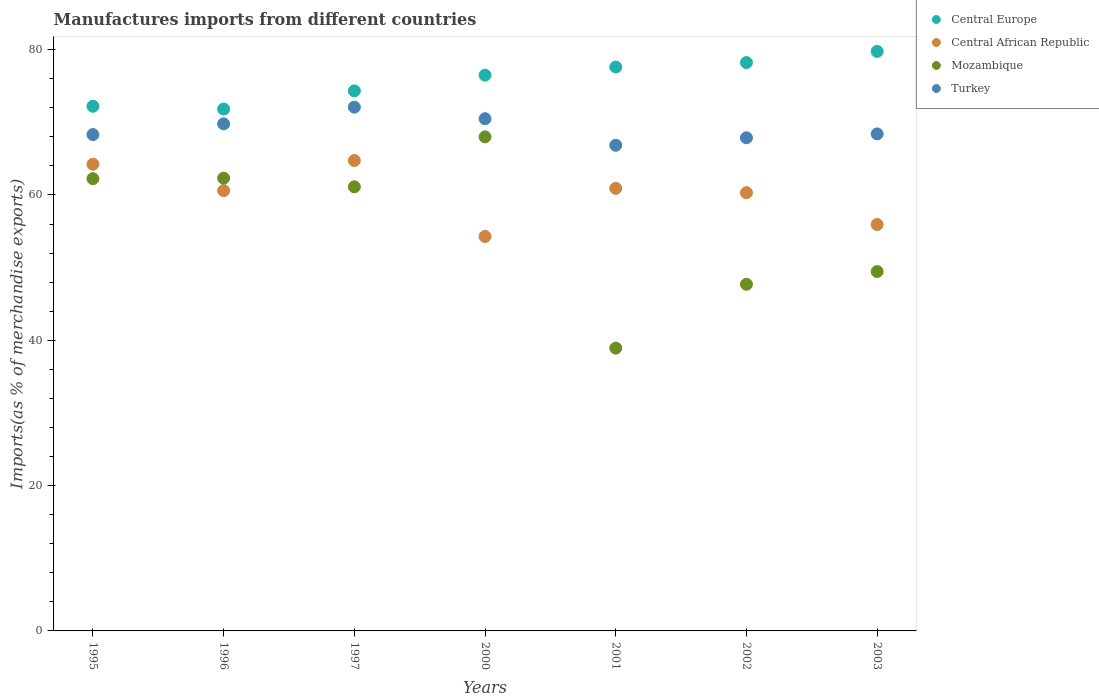Is the number of dotlines equal to the number of legend labels?
Offer a very short reply. Yes. What is the percentage of imports to different countries in Turkey in 1996?
Make the answer very short. 69.78. Across all years, what is the maximum percentage of imports to different countries in Mozambique?
Ensure brevity in your answer.  67.99. Across all years, what is the minimum percentage of imports to different countries in Central Europe?
Ensure brevity in your answer.  71.82. What is the total percentage of imports to different countries in Central Europe in the graph?
Give a very brief answer. 530.41. What is the difference between the percentage of imports to different countries in Turkey in 1997 and that in 2003?
Keep it short and to the point. 3.68. What is the difference between the percentage of imports to different countries in Turkey in 2002 and the percentage of imports to different countries in Central African Republic in 2000?
Your answer should be very brief. 13.58. What is the average percentage of imports to different countries in Turkey per year?
Your answer should be very brief. 69.11. In the year 2002, what is the difference between the percentage of imports to different countries in Central African Republic and percentage of imports to different countries in Mozambique?
Provide a short and direct response. 12.6. In how many years, is the percentage of imports to different countries in Central African Republic greater than 4 %?
Keep it short and to the point. 7. What is the ratio of the percentage of imports to different countries in Central Europe in 1996 to that in 2002?
Provide a succinct answer. 0.92. Is the percentage of imports to different countries in Turkey in 1995 less than that in 2003?
Give a very brief answer. Yes. What is the difference between the highest and the second highest percentage of imports to different countries in Turkey?
Offer a terse response. 1.59. What is the difference between the highest and the lowest percentage of imports to different countries in Mozambique?
Offer a terse response. 29.07. Is the sum of the percentage of imports to different countries in Central African Republic in 1995 and 2000 greater than the maximum percentage of imports to different countries in Central Europe across all years?
Your answer should be very brief. Yes. Is it the case that in every year, the sum of the percentage of imports to different countries in Central African Republic and percentage of imports to different countries in Turkey  is greater than the sum of percentage of imports to different countries in Central Europe and percentage of imports to different countries in Mozambique?
Provide a short and direct response. Yes. Is it the case that in every year, the sum of the percentage of imports to different countries in Turkey and percentage of imports to different countries in Mozambique  is greater than the percentage of imports to different countries in Central Europe?
Offer a very short reply. Yes. Is the percentage of imports to different countries in Central Europe strictly less than the percentage of imports to different countries in Mozambique over the years?
Your response must be concise. No. How many dotlines are there?
Your answer should be compact. 4. How many years are there in the graph?
Provide a succinct answer. 7. Are the values on the major ticks of Y-axis written in scientific E-notation?
Give a very brief answer. No. Does the graph contain any zero values?
Your answer should be very brief. No. How many legend labels are there?
Your answer should be compact. 4. What is the title of the graph?
Your response must be concise. Manufactures imports from different countries. Does "Eritrea" appear as one of the legend labels in the graph?
Offer a terse response. No. What is the label or title of the X-axis?
Provide a succinct answer. Years. What is the label or title of the Y-axis?
Make the answer very short. Imports(as % of merchandise exports). What is the Imports(as % of merchandise exports) in Central Europe in 1995?
Offer a terse response. 72.2. What is the Imports(as % of merchandise exports) in Central African Republic in 1995?
Make the answer very short. 64.22. What is the Imports(as % of merchandise exports) of Mozambique in 1995?
Offer a terse response. 62.24. What is the Imports(as % of merchandise exports) of Turkey in 1995?
Provide a short and direct response. 68.31. What is the Imports(as % of merchandise exports) of Central Europe in 1996?
Your answer should be very brief. 71.82. What is the Imports(as % of merchandise exports) of Central African Republic in 1996?
Provide a succinct answer. 60.6. What is the Imports(as % of merchandise exports) in Mozambique in 1996?
Keep it short and to the point. 62.31. What is the Imports(as % of merchandise exports) in Turkey in 1996?
Make the answer very short. 69.78. What is the Imports(as % of merchandise exports) in Central Europe in 1997?
Ensure brevity in your answer.  74.32. What is the Imports(as % of merchandise exports) of Central African Republic in 1997?
Your answer should be very brief. 64.74. What is the Imports(as % of merchandise exports) of Mozambique in 1997?
Your response must be concise. 61.12. What is the Imports(as % of merchandise exports) of Turkey in 1997?
Ensure brevity in your answer.  72.08. What is the Imports(as % of merchandise exports) in Central Europe in 2000?
Your answer should be compact. 76.49. What is the Imports(as % of merchandise exports) in Central African Republic in 2000?
Your response must be concise. 54.28. What is the Imports(as % of merchandise exports) of Mozambique in 2000?
Ensure brevity in your answer.  67.99. What is the Imports(as % of merchandise exports) in Turkey in 2000?
Give a very brief answer. 70.49. What is the Imports(as % of merchandise exports) in Central Europe in 2001?
Your answer should be very brief. 77.61. What is the Imports(as % of merchandise exports) in Central African Republic in 2001?
Your answer should be compact. 60.91. What is the Imports(as % of merchandise exports) of Mozambique in 2001?
Make the answer very short. 38.92. What is the Imports(as % of merchandise exports) in Turkey in 2001?
Offer a terse response. 66.84. What is the Imports(as % of merchandise exports) of Central Europe in 2002?
Your response must be concise. 78.22. What is the Imports(as % of merchandise exports) in Central African Republic in 2002?
Provide a short and direct response. 60.3. What is the Imports(as % of merchandise exports) of Mozambique in 2002?
Provide a short and direct response. 47.71. What is the Imports(as % of merchandise exports) of Turkey in 2002?
Give a very brief answer. 67.86. What is the Imports(as % of merchandise exports) of Central Europe in 2003?
Keep it short and to the point. 79.75. What is the Imports(as % of merchandise exports) in Central African Republic in 2003?
Give a very brief answer. 55.93. What is the Imports(as % of merchandise exports) of Mozambique in 2003?
Offer a very short reply. 49.46. What is the Imports(as % of merchandise exports) in Turkey in 2003?
Offer a very short reply. 68.4. Across all years, what is the maximum Imports(as % of merchandise exports) in Central Europe?
Your answer should be very brief. 79.75. Across all years, what is the maximum Imports(as % of merchandise exports) of Central African Republic?
Make the answer very short. 64.74. Across all years, what is the maximum Imports(as % of merchandise exports) in Mozambique?
Keep it short and to the point. 67.99. Across all years, what is the maximum Imports(as % of merchandise exports) of Turkey?
Provide a succinct answer. 72.08. Across all years, what is the minimum Imports(as % of merchandise exports) in Central Europe?
Provide a succinct answer. 71.82. Across all years, what is the minimum Imports(as % of merchandise exports) of Central African Republic?
Your answer should be very brief. 54.28. Across all years, what is the minimum Imports(as % of merchandise exports) in Mozambique?
Your answer should be compact. 38.92. Across all years, what is the minimum Imports(as % of merchandise exports) of Turkey?
Offer a very short reply. 66.84. What is the total Imports(as % of merchandise exports) in Central Europe in the graph?
Your answer should be compact. 530.41. What is the total Imports(as % of merchandise exports) of Central African Republic in the graph?
Offer a terse response. 420.98. What is the total Imports(as % of merchandise exports) in Mozambique in the graph?
Offer a terse response. 389.74. What is the total Imports(as % of merchandise exports) in Turkey in the graph?
Keep it short and to the point. 483.76. What is the difference between the Imports(as % of merchandise exports) of Central Europe in 1995 and that in 1996?
Offer a very short reply. 0.38. What is the difference between the Imports(as % of merchandise exports) of Central African Republic in 1995 and that in 1996?
Make the answer very short. 3.63. What is the difference between the Imports(as % of merchandise exports) in Mozambique in 1995 and that in 1996?
Your answer should be very brief. -0.07. What is the difference between the Imports(as % of merchandise exports) in Turkey in 1995 and that in 1996?
Keep it short and to the point. -1.47. What is the difference between the Imports(as % of merchandise exports) in Central Europe in 1995 and that in 1997?
Give a very brief answer. -2.12. What is the difference between the Imports(as % of merchandise exports) of Central African Republic in 1995 and that in 1997?
Your answer should be very brief. -0.51. What is the difference between the Imports(as % of merchandise exports) of Mozambique in 1995 and that in 1997?
Your response must be concise. 1.12. What is the difference between the Imports(as % of merchandise exports) in Turkey in 1995 and that in 1997?
Keep it short and to the point. -3.77. What is the difference between the Imports(as % of merchandise exports) of Central Europe in 1995 and that in 2000?
Your answer should be compact. -4.28. What is the difference between the Imports(as % of merchandise exports) in Central African Republic in 1995 and that in 2000?
Give a very brief answer. 9.94. What is the difference between the Imports(as % of merchandise exports) in Mozambique in 1995 and that in 2000?
Your answer should be very brief. -5.75. What is the difference between the Imports(as % of merchandise exports) of Turkey in 1995 and that in 2000?
Provide a succinct answer. -2.18. What is the difference between the Imports(as % of merchandise exports) in Central Europe in 1995 and that in 2001?
Provide a short and direct response. -5.4. What is the difference between the Imports(as % of merchandise exports) in Central African Republic in 1995 and that in 2001?
Your answer should be compact. 3.32. What is the difference between the Imports(as % of merchandise exports) of Mozambique in 1995 and that in 2001?
Make the answer very short. 23.32. What is the difference between the Imports(as % of merchandise exports) of Turkey in 1995 and that in 2001?
Your answer should be very brief. 1.47. What is the difference between the Imports(as % of merchandise exports) of Central Europe in 1995 and that in 2002?
Give a very brief answer. -6.01. What is the difference between the Imports(as % of merchandise exports) of Central African Republic in 1995 and that in 2002?
Give a very brief answer. 3.92. What is the difference between the Imports(as % of merchandise exports) in Mozambique in 1995 and that in 2002?
Ensure brevity in your answer.  14.53. What is the difference between the Imports(as % of merchandise exports) of Turkey in 1995 and that in 2002?
Provide a short and direct response. 0.44. What is the difference between the Imports(as % of merchandise exports) in Central Europe in 1995 and that in 2003?
Your response must be concise. -7.55. What is the difference between the Imports(as % of merchandise exports) in Central African Republic in 1995 and that in 2003?
Your answer should be compact. 8.29. What is the difference between the Imports(as % of merchandise exports) in Mozambique in 1995 and that in 2003?
Your answer should be compact. 12.78. What is the difference between the Imports(as % of merchandise exports) in Turkey in 1995 and that in 2003?
Your answer should be very brief. -0.09. What is the difference between the Imports(as % of merchandise exports) in Central Europe in 1996 and that in 1997?
Offer a very short reply. -2.5. What is the difference between the Imports(as % of merchandise exports) in Central African Republic in 1996 and that in 1997?
Your response must be concise. -4.14. What is the difference between the Imports(as % of merchandise exports) in Mozambique in 1996 and that in 1997?
Give a very brief answer. 1.19. What is the difference between the Imports(as % of merchandise exports) of Turkey in 1996 and that in 1997?
Make the answer very short. -2.3. What is the difference between the Imports(as % of merchandise exports) of Central Europe in 1996 and that in 2000?
Give a very brief answer. -4.66. What is the difference between the Imports(as % of merchandise exports) of Central African Republic in 1996 and that in 2000?
Offer a very short reply. 6.31. What is the difference between the Imports(as % of merchandise exports) in Mozambique in 1996 and that in 2000?
Provide a short and direct response. -5.68. What is the difference between the Imports(as % of merchandise exports) of Turkey in 1996 and that in 2000?
Provide a short and direct response. -0.71. What is the difference between the Imports(as % of merchandise exports) of Central Europe in 1996 and that in 2001?
Give a very brief answer. -5.78. What is the difference between the Imports(as % of merchandise exports) of Central African Republic in 1996 and that in 2001?
Provide a short and direct response. -0.31. What is the difference between the Imports(as % of merchandise exports) in Mozambique in 1996 and that in 2001?
Offer a very short reply. 23.39. What is the difference between the Imports(as % of merchandise exports) in Turkey in 1996 and that in 2001?
Your answer should be compact. 2.95. What is the difference between the Imports(as % of merchandise exports) in Central Europe in 1996 and that in 2002?
Offer a terse response. -6.39. What is the difference between the Imports(as % of merchandise exports) of Central African Republic in 1996 and that in 2002?
Your answer should be compact. 0.29. What is the difference between the Imports(as % of merchandise exports) of Mozambique in 1996 and that in 2002?
Provide a short and direct response. 14.6. What is the difference between the Imports(as % of merchandise exports) in Turkey in 1996 and that in 2002?
Offer a very short reply. 1.92. What is the difference between the Imports(as % of merchandise exports) in Central Europe in 1996 and that in 2003?
Give a very brief answer. -7.93. What is the difference between the Imports(as % of merchandise exports) of Central African Republic in 1996 and that in 2003?
Make the answer very short. 4.66. What is the difference between the Imports(as % of merchandise exports) in Mozambique in 1996 and that in 2003?
Your answer should be very brief. 12.85. What is the difference between the Imports(as % of merchandise exports) in Turkey in 1996 and that in 2003?
Give a very brief answer. 1.38. What is the difference between the Imports(as % of merchandise exports) of Central Europe in 1997 and that in 2000?
Provide a succinct answer. -2.16. What is the difference between the Imports(as % of merchandise exports) of Central African Republic in 1997 and that in 2000?
Offer a very short reply. 10.45. What is the difference between the Imports(as % of merchandise exports) of Mozambique in 1997 and that in 2000?
Offer a very short reply. -6.88. What is the difference between the Imports(as % of merchandise exports) of Turkey in 1997 and that in 2000?
Make the answer very short. 1.59. What is the difference between the Imports(as % of merchandise exports) in Central Europe in 1997 and that in 2001?
Provide a short and direct response. -3.29. What is the difference between the Imports(as % of merchandise exports) of Central African Republic in 1997 and that in 2001?
Provide a short and direct response. 3.83. What is the difference between the Imports(as % of merchandise exports) of Mozambique in 1997 and that in 2001?
Keep it short and to the point. 22.2. What is the difference between the Imports(as % of merchandise exports) in Turkey in 1997 and that in 2001?
Your answer should be compact. 5.25. What is the difference between the Imports(as % of merchandise exports) in Central Europe in 1997 and that in 2002?
Provide a succinct answer. -3.89. What is the difference between the Imports(as % of merchandise exports) of Central African Republic in 1997 and that in 2002?
Offer a terse response. 4.43. What is the difference between the Imports(as % of merchandise exports) of Mozambique in 1997 and that in 2002?
Provide a succinct answer. 13.41. What is the difference between the Imports(as % of merchandise exports) in Turkey in 1997 and that in 2002?
Give a very brief answer. 4.22. What is the difference between the Imports(as % of merchandise exports) in Central Europe in 1997 and that in 2003?
Offer a very short reply. -5.43. What is the difference between the Imports(as % of merchandise exports) in Central African Republic in 1997 and that in 2003?
Make the answer very short. 8.8. What is the difference between the Imports(as % of merchandise exports) in Mozambique in 1997 and that in 2003?
Your answer should be compact. 11.66. What is the difference between the Imports(as % of merchandise exports) of Turkey in 1997 and that in 2003?
Offer a terse response. 3.68. What is the difference between the Imports(as % of merchandise exports) in Central Europe in 2000 and that in 2001?
Your answer should be very brief. -1.12. What is the difference between the Imports(as % of merchandise exports) in Central African Republic in 2000 and that in 2001?
Make the answer very short. -6.62. What is the difference between the Imports(as % of merchandise exports) of Mozambique in 2000 and that in 2001?
Your response must be concise. 29.07. What is the difference between the Imports(as % of merchandise exports) of Turkey in 2000 and that in 2001?
Give a very brief answer. 3.65. What is the difference between the Imports(as % of merchandise exports) of Central Europe in 2000 and that in 2002?
Ensure brevity in your answer.  -1.73. What is the difference between the Imports(as % of merchandise exports) of Central African Republic in 2000 and that in 2002?
Your answer should be very brief. -6.02. What is the difference between the Imports(as % of merchandise exports) in Mozambique in 2000 and that in 2002?
Provide a short and direct response. 20.29. What is the difference between the Imports(as % of merchandise exports) of Turkey in 2000 and that in 2002?
Ensure brevity in your answer.  2.63. What is the difference between the Imports(as % of merchandise exports) in Central Europe in 2000 and that in 2003?
Your answer should be compact. -3.27. What is the difference between the Imports(as % of merchandise exports) in Central African Republic in 2000 and that in 2003?
Your answer should be very brief. -1.65. What is the difference between the Imports(as % of merchandise exports) in Mozambique in 2000 and that in 2003?
Offer a very short reply. 18.54. What is the difference between the Imports(as % of merchandise exports) in Turkey in 2000 and that in 2003?
Your answer should be compact. 2.09. What is the difference between the Imports(as % of merchandise exports) of Central Europe in 2001 and that in 2002?
Give a very brief answer. -0.61. What is the difference between the Imports(as % of merchandise exports) of Central African Republic in 2001 and that in 2002?
Ensure brevity in your answer.  0.6. What is the difference between the Imports(as % of merchandise exports) in Mozambique in 2001 and that in 2002?
Ensure brevity in your answer.  -8.79. What is the difference between the Imports(as % of merchandise exports) of Turkey in 2001 and that in 2002?
Ensure brevity in your answer.  -1.03. What is the difference between the Imports(as % of merchandise exports) of Central Europe in 2001 and that in 2003?
Your response must be concise. -2.15. What is the difference between the Imports(as % of merchandise exports) in Central African Republic in 2001 and that in 2003?
Give a very brief answer. 4.97. What is the difference between the Imports(as % of merchandise exports) in Mozambique in 2001 and that in 2003?
Ensure brevity in your answer.  -10.54. What is the difference between the Imports(as % of merchandise exports) in Turkey in 2001 and that in 2003?
Provide a succinct answer. -1.57. What is the difference between the Imports(as % of merchandise exports) in Central Europe in 2002 and that in 2003?
Give a very brief answer. -1.54. What is the difference between the Imports(as % of merchandise exports) of Central African Republic in 2002 and that in 2003?
Ensure brevity in your answer.  4.37. What is the difference between the Imports(as % of merchandise exports) in Mozambique in 2002 and that in 2003?
Provide a succinct answer. -1.75. What is the difference between the Imports(as % of merchandise exports) of Turkey in 2002 and that in 2003?
Offer a very short reply. -0.54. What is the difference between the Imports(as % of merchandise exports) in Central Europe in 1995 and the Imports(as % of merchandise exports) in Central African Republic in 1996?
Keep it short and to the point. 11.61. What is the difference between the Imports(as % of merchandise exports) of Central Europe in 1995 and the Imports(as % of merchandise exports) of Mozambique in 1996?
Provide a short and direct response. 9.89. What is the difference between the Imports(as % of merchandise exports) in Central Europe in 1995 and the Imports(as % of merchandise exports) in Turkey in 1996?
Offer a very short reply. 2.42. What is the difference between the Imports(as % of merchandise exports) in Central African Republic in 1995 and the Imports(as % of merchandise exports) in Mozambique in 1996?
Offer a terse response. 1.92. What is the difference between the Imports(as % of merchandise exports) of Central African Republic in 1995 and the Imports(as % of merchandise exports) of Turkey in 1996?
Make the answer very short. -5.56. What is the difference between the Imports(as % of merchandise exports) in Mozambique in 1995 and the Imports(as % of merchandise exports) in Turkey in 1996?
Ensure brevity in your answer.  -7.54. What is the difference between the Imports(as % of merchandise exports) in Central Europe in 1995 and the Imports(as % of merchandise exports) in Central African Republic in 1997?
Give a very brief answer. 7.47. What is the difference between the Imports(as % of merchandise exports) of Central Europe in 1995 and the Imports(as % of merchandise exports) of Mozambique in 1997?
Ensure brevity in your answer.  11.09. What is the difference between the Imports(as % of merchandise exports) in Central Europe in 1995 and the Imports(as % of merchandise exports) in Turkey in 1997?
Keep it short and to the point. 0.12. What is the difference between the Imports(as % of merchandise exports) of Central African Republic in 1995 and the Imports(as % of merchandise exports) of Mozambique in 1997?
Your answer should be compact. 3.11. What is the difference between the Imports(as % of merchandise exports) of Central African Republic in 1995 and the Imports(as % of merchandise exports) of Turkey in 1997?
Your answer should be compact. -7.86. What is the difference between the Imports(as % of merchandise exports) in Mozambique in 1995 and the Imports(as % of merchandise exports) in Turkey in 1997?
Offer a terse response. -9.84. What is the difference between the Imports(as % of merchandise exports) in Central Europe in 1995 and the Imports(as % of merchandise exports) in Central African Republic in 2000?
Make the answer very short. 17.92. What is the difference between the Imports(as % of merchandise exports) in Central Europe in 1995 and the Imports(as % of merchandise exports) in Mozambique in 2000?
Offer a terse response. 4.21. What is the difference between the Imports(as % of merchandise exports) in Central Europe in 1995 and the Imports(as % of merchandise exports) in Turkey in 2000?
Provide a succinct answer. 1.71. What is the difference between the Imports(as % of merchandise exports) in Central African Republic in 1995 and the Imports(as % of merchandise exports) in Mozambique in 2000?
Offer a very short reply. -3.77. What is the difference between the Imports(as % of merchandise exports) in Central African Republic in 1995 and the Imports(as % of merchandise exports) in Turkey in 2000?
Your answer should be compact. -6.26. What is the difference between the Imports(as % of merchandise exports) of Mozambique in 1995 and the Imports(as % of merchandise exports) of Turkey in 2000?
Offer a very short reply. -8.25. What is the difference between the Imports(as % of merchandise exports) in Central Europe in 1995 and the Imports(as % of merchandise exports) in Central African Republic in 2001?
Your response must be concise. 11.3. What is the difference between the Imports(as % of merchandise exports) in Central Europe in 1995 and the Imports(as % of merchandise exports) in Mozambique in 2001?
Offer a terse response. 33.28. What is the difference between the Imports(as % of merchandise exports) of Central Europe in 1995 and the Imports(as % of merchandise exports) of Turkey in 2001?
Offer a very short reply. 5.37. What is the difference between the Imports(as % of merchandise exports) of Central African Republic in 1995 and the Imports(as % of merchandise exports) of Mozambique in 2001?
Offer a very short reply. 25.3. What is the difference between the Imports(as % of merchandise exports) in Central African Republic in 1995 and the Imports(as % of merchandise exports) in Turkey in 2001?
Offer a terse response. -2.61. What is the difference between the Imports(as % of merchandise exports) in Mozambique in 1995 and the Imports(as % of merchandise exports) in Turkey in 2001?
Your response must be concise. -4.59. What is the difference between the Imports(as % of merchandise exports) of Central Europe in 1995 and the Imports(as % of merchandise exports) of Central African Republic in 2002?
Ensure brevity in your answer.  11.9. What is the difference between the Imports(as % of merchandise exports) of Central Europe in 1995 and the Imports(as % of merchandise exports) of Mozambique in 2002?
Offer a terse response. 24.5. What is the difference between the Imports(as % of merchandise exports) in Central Europe in 1995 and the Imports(as % of merchandise exports) in Turkey in 2002?
Give a very brief answer. 4.34. What is the difference between the Imports(as % of merchandise exports) in Central African Republic in 1995 and the Imports(as % of merchandise exports) in Mozambique in 2002?
Provide a succinct answer. 16.52. What is the difference between the Imports(as % of merchandise exports) in Central African Republic in 1995 and the Imports(as % of merchandise exports) in Turkey in 2002?
Your answer should be very brief. -3.64. What is the difference between the Imports(as % of merchandise exports) in Mozambique in 1995 and the Imports(as % of merchandise exports) in Turkey in 2002?
Give a very brief answer. -5.62. What is the difference between the Imports(as % of merchandise exports) in Central Europe in 1995 and the Imports(as % of merchandise exports) in Central African Republic in 2003?
Offer a very short reply. 16.27. What is the difference between the Imports(as % of merchandise exports) of Central Europe in 1995 and the Imports(as % of merchandise exports) of Mozambique in 2003?
Your response must be concise. 22.75. What is the difference between the Imports(as % of merchandise exports) of Central Europe in 1995 and the Imports(as % of merchandise exports) of Turkey in 2003?
Your answer should be compact. 3.8. What is the difference between the Imports(as % of merchandise exports) in Central African Republic in 1995 and the Imports(as % of merchandise exports) in Mozambique in 2003?
Your response must be concise. 14.77. What is the difference between the Imports(as % of merchandise exports) of Central African Republic in 1995 and the Imports(as % of merchandise exports) of Turkey in 2003?
Ensure brevity in your answer.  -4.18. What is the difference between the Imports(as % of merchandise exports) of Mozambique in 1995 and the Imports(as % of merchandise exports) of Turkey in 2003?
Offer a terse response. -6.16. What is the difference between the Imports(as % of merchandise exports) in Central Europe in 1996 and the Imports(as % of merchandise exports) in Central African Republic in 1997?
Provide a succinct answer. 7.09. What is the difference between the Imports(as % of merchandise exports) in Central Europe in 1996 and the Imports(as % of merchandise exports) in Mozambique in 1997?
Keep it short and to the point. 10.71. What is the difference between the Imports(as % of merchandise exports) of Central Europe in 1996 and the Imports(as % of merchandise exports) of Turkey in 1997?
Offer a terse response. -0.26. What is the difference between the Imports(as % of merchandise exports) in Central African Republic in 1996 and the Imports(as % of merchandise exports) in Mozambique in 1997?
Your answer should be very brief. -0.52. What is the difference between the Imports(as % of merchandise exports) in Central African Republic in 1996 and the Imports(as % of merchandise exports) in Turkey in 1997?
Offer a terse response. -11.49. What is the difference between the Imports(as % of merchandise exports) in Mozambique in 1996 and the Imports(as % of merchandise exports) in Turkey in 1997?
Provide a short and direct response. -9.77. What is the difference between the Imports(as % of merchandise exports) in Central Europe in 1996 and the Imports(as % of merchandise exports) in Central African Republic in 2000?
Give a very brief answer. 17.54. What is the difference between the Imports(as % of merchandise exports) in Central Europe in 1996 and the Imports(as % of merchandise exports) in Mozambique in 2000?
Provide a succinct answer. 3.83. What is the difference between the Imports(as % of merchandise exports) of Central Europe in 1996 and the Imports(as % of merchandise exports) of Turkey in 2000?
Your answer should be compact. 1.33. What is the difference between the Imports(as % of merchandise exports) of Central African Republic in 1996 and the Imports(as % of merchandise exports) of Mozambique in 2000?
Offer a terse response. -7.4. What is the difference between the Imports(as % of merchandise exports) of Central African Republic in 1996 and the Imports(as % of merchandise exports) of Turkey in 2000?
Offer a very short reply. -9.89. What is the difference between the Imports(as % of merchandise exports) in Mozambique in 1996 and the Imports(as % of merchandise exports) in Turkey in 2000?
Your answer should be very brief. -8.18. What is the difference between the Imports(as % of merchandise exports) of Central Europe in 1996 and the Imports(as % of merchandise exports) of Central African Republic in 2001?
Give a very brief answer. 10.92. What is the difference between the Imports(as % of merchandise exports) in Central Europe in 1996 and the Imports(as % of merchandise exports) in Mozambique in 2001?
Ensure brevity in your answer.  32.9. What is the difference between the Imports(as % of merchandise exports) of Central Europe in 1996 and the Imports(as % of merchandise exports) of Turkey in 2001?
Offer a very short reply. 4.99. What is the difference between the Imports(as % of merchandise exports) of Central African Republic in 1996 and the Imports(as % of merchandise exports) of Mozambique in 2001?
Your response must be concise. 21.68. What is the difference between the Imports(as % of merchandise exports) in Central African Republic in 1996 and the Imports(as % of merchandise exports) in Turkey in 2001?
Make the answer very short. -6.24. What is the difference between the Imports(as % of merchandise exports) of Mozambique in 1996 and the Imports(as % of merchandise exports) of Turkey in 2001?
Ensure brevity in your answer.  -4.53. What is the difference between the Imports(as % of merchandise exports) in Central Europe in 1996 and the Imports(as % of merchandise exports) in Central African Republic in 2002?
Make the answer very short. 11.52. What is the difference between the Imports(as % of merchandise exports) in Central Europe in 1996 and the Imports(as % of merchandise exports) in Mozambique in 2002?
Give a very brief answer. 24.12. What is the difference between the Imports(as % of merchandise exports) in Central Europe in 1996 and the Imports(as % of merchandise exports) in Turkey in 2002?
Provide a short and direct response. 3.96. What is the difference between the Imports(as % of merchandise exports) in Central African Republic in 1996 and the Imports(as % of merchandise exports) in Mozambique in 2002?
Ensure brevity in your answer.  12.89. What is the difference between the Imports(as % of merchandise exports) in Central African Republic in 1996 and the Imports(as % of merchandise exports) in Turkey in 2002?
Give a very brief answer. -7.27. What is the difference between the Imports(as % of merchandise exports) of Mozambique in 1996 and the Imports(as % of merchandise exports) of Turkey in 2002?
Offer a terse response. -5.56. What is the difference between the Imports(as % of merchandise exports) of Central Europe in 1996 and the Imports(as % of merchandise exports) of Central African Republic in 2003?
Make the answer very short. 15.89. What is the difference between the Imports(as % of merchandise exports) in Central Europe in 1996 and the Imports(as % of merchandise exports) in Mozambique in 2003?
Give a very brief answer. 22.37. What is the difference between the Imports(as % of merchandise exports) of Central Europe in 1996 and the Imports(as % of merchandise exports) of Turkey in 2003?
Provide a succinct answer. 3.42. What is the difference between the Imports(as % of merchandise exports) of Central African Republic in 1996 and the Imports(as % of merchandise exports) of Mozambique in 2003?
Your answer should be very brief. 11.14. What is the difference between the Imports(as % of merchandise exports) in Central African Republic in 1996 and the Imports(as % of merchandise exports) in Turkey in 2003?
Make the answer very short. -7.81. What is the difference between the Imports(as % of merchandise exports) of Mozambique in 1996 and the Imports(as % of merchandise exports) of Turkey in 2003?
Keep it short and to the point. -6.09. What is the difference between the Imports(as % of merchandise exports) of Central Europe in 1997 and the Imports(as % of merchandise exports) of Central African Republic in 2000?
Your answer should be very brief. 20.04. What is the difference between the Imports(as % of merchandise exports) of Central Europe in 1997 and the Imports(as % of merchandise exports) of Mozambique in 2000?
Your answer should be compact. 6.33. What is the difference between the Imports(as % of merchandise exports) of Central Europe in 1997 and the Imports(as % of merchandise exports) of Turkey in 2000?
Ensure brevity in your answer.  3.83. What is the difference between the Imports(as % of merchandise exports) in Central African Republic in 1997 and the Imports(as % of merchandise exports) in Mozambique in 2000?
Your answer should be compact. -3.26. What is the difference between the Imports(as % of merchandise exports) of Central African Republic in 1997 and the Imports(as % of merchandise exports) of Turkey in 2000?
Your response must be concise. -5.75. What is the difference between the Imports(as % of merchandise exports) in Mozambique in 1997 and the Imports(as % of merchandise exports) in Turkey in 2000?
Your answer should be very brief. -9.37. What is the difference between the Imports(as % of merchandise exports) of Central Europe in 1997 and the Imports(as % of merchandise exports) of Central African Republic in 2001?
Your response must be concise. 13.42. What is the difference between the Imports(as % of merchandise exports) of Central Europe in 1997 and the Imports(as % of merchandise exports) of Mozambique in 2001?
Provide a short and direct response. 35.4. What is the difference between the Imports(as % of merchandise exports) in Central Europe in 1997 and the Imports(as % of merchandise exports) in Turkey in 2001?
Your response must be concise. 7.49. What is the difference between the Imports(as % of merchandise exports) of Central African Republic in 1997 and the Imports(as % of merchandise exports) of Mozambique in 2001?
Give a very brief answer. 25.82. What is the difference between the Imports(as % of merchandise exports) in Central African Republic in 1997 and the Imports(as % of merchandise exports) in Turkey in 2001?
Make the answer very short. -2.1. What is the difference between the Imports(as % of merchandise exports) of Mozambique in 1997 and the Imports(as % of merchandise exports) of Turkey in 2001?
Your answer should be very brief. -5.72. What is the difference between the Imports(as % of merchandise exports) in Central Europe in 1997 and the Imports(as % of merchandise exports) in Central African Republic in 2002?
Provide a short and direct response. 14.02. What is the difference between the Imports(as % of merchandise exports) of Central Europe in 1997 and the Imports(as % of merchandise exports) of Mozambique in 2002?
Provide a short and direct response. 26.61. What is the difference between the Imports(as % of merchandise exports) in Central Europe in 1997 and the Imports(as % of merchandise exports) in Turkey in 2002?
Provide a succinct answer. 6.46. What is the difference between the Imports(as % of merchandise exports) of Central African Republic in 1997 and the Imports(as % of merchandise exports) of Mozambique in 2002?
Make the answer very short. 17.03. What is the difference between the Imports(as % of merchandise exports) of Central African Republic in 1997 and the Imports(as % of merchandise exports) of Turkey in 2002?
Offer a very short reply. -3.13. What is the difference between the Imports(as % of merchandise exports) in Mozambique in 1997 and the Imports(as % of merchandise exports) in Turkey in 2002?
Give a very brief answer. -6.75. What is the difference between the Imports(as % of merchandise exports) of Central Europe in 1997 and the Imports(as % of merchandise exports) of Central African Republic in 2003?
Provide a short and direct response. 18.39. What is the difference between the Imports(as % of merchandise exports) of Central Europe in 1997 and the Imports(as % of merchandise exports) of Mozambique in 2003?
Provide a succinct answer. 24.86. What is the difference between the Imports(as % of merchandise exports) of Central Europe in 1997 and the Imports(as % of merchandise exports) of Turkey in 2003?
Offer a terse response. 5.92. What is the difference between the Imports(as % of merchandise exports) in Central African Republic in 1997 and the Imports(as % of merchandise exports) in Mozambique in 2003?
Your answer should be very brief. 15.28. What is the difference between the Imports(as % of merchandise exports) of Central African Republic in 1997 and the Imports(as % of merchandise exports) of Turkey in 2003?
Keep it short and to the point. -3.67. What is the difference between the Imports(as % of merchandise exports) in Mozambique in 1997 and the Imports(as % of merchandise exports) in Turkey in 2003?
Your response must be concise. -7.29. What is the difference between the Imports(as % of merchandise exports) in Central Europe in 2000 and the Imports(as % of merchandise exports) in Central African Republic in 2001?
Your answer should be very brief. 15.58. What is the difference between the Imports(as % of merchandise exports) in Central Europe in 2000 and the Imports(as % of merchandise exports) in Mozambique in 2001?
Keep it short and to the point. 37.57. What is the difference between the Imports(as % of merchandise exports) in Central Europe in 2000 and the Imports(as % of merchandise exports) in Turkey in 2001?
Make the answer very short. 9.65. What is the difference between the Imports(as % of merchandise exports) of Central African Republic in 2000 and the Imports(as % of merchandise exports) of Mozambique in 2001?
Make the answer very short. 15.36. What is the difference between the Imports(as % of merchandise exports) of Central African Republic in 2000 and the Imports(as % of merchandise exports) of Turkey in 2001?
Offer a very short reply. -12.55. What is the difference between the Imports(as % of merchandise exports) of Mozambique in 2000 and the Imports(as % of merchandise exports) of Turkey in 2001?
Give a very brief answer. 1.16. What is the difference between the Imports(as % of merchandise exports) in Central Europe in 2000 and the Imports(as % of merchandise exports) in Central African Republic in 2002?
Give a very brief answer. 16.18. What is the difference between the Imports(as % of merchandise exports) in Central Europe in 2000 and the Imports(as % of merchandise exports) in Mozambique in 2002?
Your answer should be compact. 28.78. What is the difference between the Imports(as % of merchandise exports) in Central Europe in 2000 and the Imports(as % of merchandise exports) in Turkey in 2002?
Provide a succinct answer. 8.62. What is the difference between the Imports(as % of merchandise exports) of Central African Republic in 2000 and the Imports(as % of merchandise exports) of Mozambique in 2002?
Give a very brief answer. 6.58. What is the difference between the Imports(as % of merchandise exports) in Central African Republic in 2000 and the Imports(as % of merchandise exports) in Turkey in 2002?
Offer a very short reply. -13.58. What is the difference between the Imports(as % of merchandise exports) of Mozambique in 2000 and the Imports(as % of merchandise exports) of Turkey in 2002?
Provide a short and direct response. 0.13. What is the difference between the Imports(as % of merchandise exports) in Central Europe in 2000 and the Imports(as % of merchandise exports) in Central African Republic in 2003?
Offer a very short reply. 20.55. What is the difference between the Imports(as % of merchandise exports) of Central Europe in 2000 and the Imports(as % of merchandise exports) of Mozambique in 2003?
Ensure brevity in your answer.  27.03. What is the difference between the Imports(as % of merchandise exports) in Central Europe in 2000 and the Imports(as % of merchandise exports) in Turkey in 2003?
Give a very brief answer. 8.08. What is the difference between the Imports(as % of merchandise exports) of Central African Republic in 2000 and the Imports(as % of merchandise exports) of Mozambique in 2003?
Ensure brevity in your answer.  4.83. What is the difference between the Imports(as % of merchandise exports) of Central African Republic in 2000 and the Imports(as % of merchandise exports) of Turkey in 2003?
Make the answer very short. -14.12. What is the difference between the Imports(as % of merchandise exports) in Mozambique in 2000 and the Imports(as % of merchandise exports) in Turkey in 2003?
Offer a very short reply. -0.41. What is the difference between the Imports(as % of merchandise exports) in Central Europe in 2001 and the Imports(as % of merchandise exports) in Central African Republic in 2002?
Ensure brevity in your answer.  17.3. What is the difference between the Imports(as % of merchandise exports) in Central Europe in 2001 and the Imports(as % of merchandise exports) in Mozambique in 2002?
Give a very brief answer. 29.9. What is the difference between the Imports(as % of merchandise exports) of Central Europe in 2001 and the Imports(as % of merchandise exports) of Turkey in 2002?
Your response must be concise. 9.74. What is the difference between the Imports(as % of merchandise exports) in Central African Republic in 2001 and the Imports(as % of merchandise exports) in Mozambique in 2002?
Give a very brief answer. 13.2. What is the difference between the Imports(as % of merchandise exports) in Central African Republic in 2001 and the Imports(as % of merchandise exports) in Turkey in 2002?
Keep it short and to the point. -6.96. What is the difference between the Imports(as % of merchandise exports) of Mozambique in 2001 and the Imports(as % of merchandise exports) of Turkey in 2002?
Offer a terse response. -28.94. What is the difference between the Imports(as % of merchandise exports) of Central Europe in 2001 and the Imports(as % of merchandise exports) of Central African Republic in 2003?
Make the answer very short. 21.67. What is the difference between the Imports(as % of merchandise exports) in Central Europe in 2001 and the Imports(as % of merchandise exports) in Mozambique in 2003?
Provide a succinct answer. 28.15. What is the difference between the Imports(as % of merchandise exports) in Central Europe in 2001 and the Imports(as % of merchandise exports) in Turkey in 2003?
Ensure brevity in your answer.  9.2. What is the difference between the Imports(as % of merchandise exports) in Central African Republic in 2001 and the Imports(as % of merchandise exports) in Mozambique in 2003?
Your response must be concise. 11.45. What is the difference between the Imports(as % of merchandise exports) of Central African Republic in 2001 and the Imports(as % of merchandise exports) of Turkey in 2003?
Make the answer very short. -7.5. What is the difference between the Imports(as % of merchandise exports) of Mozambique in 2001 and the Imports(as % of merchandise exports) of Turkey in 2003?
Keep it short and to the point. -29.48. What is the difference between the Imports(as % of merchandise exports) in Central Europe in 2002 and the Imports(as % of merchandise exports) in Central African Republic in 2003?
Your answer should be compact. 22.28. What is the difference between the Imports(as % of merchandise exports) in Central Europe in 2002 and the Imports(as % of merchandise exports) in Mozambique in 2003?
Ensure brevity in your answer.  28.76. What is the difference between the Imports(as % of merchandise exports) in Central Europe in 2002 and the Imports(as % of merchandise exports) in Turkey in 2003?
Offer a terse response. 9.81. What is the difference between the Imports(as % of merchandise exports) of Central African Republic in 2002 and the Imports(as % of merchandise exports) of Mozambique in 2003?
Your answer should be very brief. 10.85. What is the difference between the Imports(as % of merchandise exports) in Central African Republic in 2002 and the Imports(as % of merchandise exports) in Turkey in 2003?
Your answer should be compact. -8.1. What is the difference between the Imports(as % of merchandise exports) in Mozambique in 2002 and the Imports(as % of merchandise exports) in Turkey in 2003?
Your response must be concise. -20.7. What is the average Imports(as % of merchandise exports) of Central Europe per year?
Your answer should be very brief. 75.77. What is the average Imports(as % of merchandise exports) of Central African Republic per year?
Give a very brief answer. 60.14. What is the average Imports(as % of merchandise exports) of Mozambique per year?
Give a very brief answer. 55.68. What is the average Imports(as % of merchandise exports) of Turkey per year?
Offer a very short reply. 69.11. In the year 1995, what is the difference between the Imports(as % of merchandise exports) of Central Europe and Imports(as % of merchandise exports) of Central African Republic?
Offer a very short reply. 7.98. In the year 1995, what is the difference between the Imports(as % of merchandise exports) in Central Europe and Imports(as % of merchandise exports) in Mozambique?
Your answer should be very brief. 9.96. In the year 1995, what is the difference between the Imports(as % of merchandise exports) of Central Europe and Imports(as % of merchandise exports) of Turkey?
Keep it short and to the point. 3.89. In the year 1995, what is the difference between the Imports(as % of merchandise exports) of Central African Republic and Imports(as % of merchandise exports) of Mozambique?
Provide a short and direct response. 1.98. In the year 1995, what is the difference between the Imports(as % of merchandise exports) of Central African Republic and Imports(as % of merchandise exports) of Turkey?
Provide a short and direct response. -4.08. In the year 1995, what is the difference between the Imports(as % of merchandise exports) in Mozambique and Imports(as % of merchandise exports) in Turkey?
Your answer should be very brief. -6.07. In the year 1996, what is the difference between the Imports(as % of merchandise exports) of Central Europe and Imports(as % of merchandise exports) of Central African Republic?
Provide a short and direct response. 11.23. In the year 1996, what is the difference between the Imports(as % of merchandise exports) of Central Europe and Imports(as % of merchandise exports) of Mozambique?
Your answer should be compact. 9.52. In the year 1996, what is the difference between the Imports(as % of merchandise exports) of Central Europe and Imports(as % of merchandise exports) of Turkey?
Provide a short and direct response. 2.04. In the year 1996, what is the difference between the Imports(as % of merchandise exports) in Central African Republic and Imports(as % of merchandise exports) in Mozambique?
Your answer should be compact. -1.71. In the year 1996, what is the difference between the Imports(as % of merchandise exports) of Central African Republic and Imports(as % of merchandise exports) of Turkey?
Offer a terse response. -9.19. In the year 1996, what is the difference between the Imports(as % of merchandise exports) of Mozambique and Imports(as % of merchandise exports) of Turkey?
Your answer should be very brief. -7.47. In the year 1997, what is the difference between the Imports(as % of merchandise exports) in Central Europe and Imports(as % of merchandise exports) in Central African Republic?
Your response must be concise. 9.58. In the year 1997, what is the difference between the Imports(as % of merchandise exports) in Central Europe and Imports(as % of merchandise exports) in Mozambique?
Offer a very short reply. 13.21. In the year 1997, what is the difference between the Imports(as % of merchandise exports) in Central Europe and Imports(as % of merchandise exports) in Turkey?
Your response must be concise. 2.24. In the year 1997, what is the difference between the Imports(as % of merchandise exports) of Central African Republic and Imports(as % of merchandise exports) of Mozambique?
Your response must be concise. 3.62. In the year 1997, what is the difference between the Imports(as % of merchandise exports) in Central African Republic and Imports(as % of merchandise exports) in Turkey?
Your response must be concise. -7.35. In the year 1997, what is the difference between the Imports(as % of merchandise exports) in Mozambique and Imports(as % of merchandise exports) in Turkey?
Your answer should be compact. -10.97. In the year 2000, what is the difference between the Imports(as % of merchandise exports) in Central Europe and Imports(as % of merchandise exports) in Central African Republic?
Ensure brevity in your answer.  22.2. In the year 2000, what is the difference between the Imports(as % of merchandise exports) of Central Europe and Imports(as % of merchandise exports) of Mozambique?
Your answer should be very brief. 8.49. In the year 2000, what is the difference between the Imports(as % of merchandise exports) of Central Europe and Imports(as % of merchandise exports) of Turkey?
Keep it short and to the point. 6. In the year 2000, what is the difference between the Imports(as % of merchandise exports) in Central African Republic and Imports(as % of merchandise exports) in Mozambique?
Provide a succinct answer. -13.71. In the year 2000, what is the difference between the Imports(as % of merchandise exports) of Central African Republic and Imports(as % of merchandise exports) of Turkey?
Give a very brief answer. -16.2. In the year 2000, what is the difference between the Imports(as % of merchandise exports) in Mozambique and Imports(as % of merchandise exports) in Turkey?
Provide a succinct answer. -2.5. In the year 2001, what is the difference between the Imports(as % of merchandise exports) in Central Europe and Imports(as % of merchandise exports) in Central African Republic?
Offer a very short reply. 16.7. In the year 2001, what is the difference between the Imports(as % of merchandise exports) in Central Europe and Imports(as % of merchandise exports) in Mozambique?
Provide a short and direct response. 38.69. In the year 2001, what is the difference between the Imports(as % of merchandise exports) of Central Europe and Imports(as % of merchandise exports) of Turkey?
Make the answer very short. 10.77. In the year 2001, what is the difference between the Imports(as % of merchandise exports) of Central African Republic and Imports(as % of merchandise exports) of Mozambique?
Offer a terse response. 21.99. In the year 2001, what is the difference between the Imports(as % of merchandise exports) of Central African Republic and Imports(as % of merchandise exports) of Turkey?
Your answer should be very brief. -5.93. In the year 2001, what is the difference between the Imports(as % of merchandise exports) of Mozambique and Imports(as % of merchandise exports) of Turkey?
Give a very brief answer. -27.92. In the year 2002, what is the difference between the Imports(as % of merchandise exports) of Central Europe and Imports(as % of merchandise exports) of Central African Republic?
Your answer should be compact. 17.91. In the year 2002, what is the difference between the Imports(as % of merchandise exports) of Central Europe and Imports(as % of merchandise exports) of Mozambique?
Offer a terse response. 30.51. In the year 2002, what is the difference between the Imports(as % of merchandise exports) of Central Europe and Imports(as % of merchandise exports) of Turkey?
Offer a terse response. 10.35. In the year 2002, what is the difference between the Imports(as % of merchandise exports) in Central African Republic and Imports(as % of merchandise exports) in Mozambique?
Your answer should be very brief. 12.6. In the year 2002, what is the difference between the Imports(as % of merchandise exports) of Central African Republic and Imports(as % of merchandise exports) of Turkey?
Ensure brevity in your answer.  -7.56. In the year 2002, what is the difference between the Imports(as % of merchandise exports) in Mozambique and Imports(as % of merchandise exports) in Turkey?
Provide a short and direct response. -20.16. In the year 2003, what is the difference between the Imports(as % of merchandise exports) in Central Europe and Imports(as % of merchandise exports) in Central African Republic?
Provide a short and direct response. 23.82. In the year 2003, what is the difference between the Imports(as % of merchandise exports) in Central Europe and Imports(as % of merchandise exports) in Mozambique?
Offer a terse response. 30.3. In the year 2003, what is the difference between the Imports(as % of merchandise exports) in Central Europe and Imports(as % of merchandise exports) in Turkey?
Keep it short and to the point. 11.35. In the year 2003, what is the difference between the Imports(as % of merchandise exports) of Central African Republic and Imports(as % of merchandise exports) of Mozambique?
Ensure brevity in your answer.  6.48. In the year 2003, what is the difference between the Imports(as % of merchandise exports) in Central African Republic and Imports(as % of merchandise exports) in Turkey?
Your answer should be compact. -12.47. In the year 2003, what is the difference between the Imports(as % of merchandise exports) of Mozambique and Imports(as % of merchandise exports) of Turkey?
Provide a short and direct response. -18.95. What is the ratio of the Imports(as % of merchandise exports) of Central African Republic in 1995 to that in 1996?
Ensure brevity in your answer.  1.06. What is the ratio of the Imports(as % of merchandise exports) of Turkey in 1995 to that in 1996?
Offer a very short reply. 0.98. What is the ratio of the Imports(as % of merchandise exports) of Central Europe in 1995 to that in 1997?
Your answer should be compact. 0.97. What is the ratio of the Imports(as % of merchandise exports) in Mozambique in 1995 to that in 1997?
Your answer should be compact. 1.02. What is the ratio of the Imports(as % of merchandise exports) of Turkey in 1995 to that in 1997?
Provide a succinct answer. 0.95. What is the ratio of the Imports(as % of merchandise exports) in Central Europe in 1995 to that in 2000?
Provide a short and direct response. 0.94. What is the ratio of the Imports(as % of merchandise exports) of Central African Republic in 1995 to that in 2000?
Ensure brevity in your answer.  1.18. What is the ratio of the Imports(as % of merchandise exports) in Mozambique in 1995 to that in 2000?
Ensure brevity in your answer.  0.92. What is the ratio of the Imports(as % of merchandise exports) in Turkey in 1995 to that in 2000?
Keep it short and to the point. 0.97. What is the ratio of the Imports(as % of merchandise exports) of Central Europe in 1995 to that in 2001?
Keep it short and to the point. 0.93. What is the ratio of the Imports(as % of merchandise exports) in Central African Republic in 1995 to that in 2001?
Offer a terse response. 1.05. What is the ratio of the Imports(as % of merchandise exports) in Mozambique in 1995 to that in 2001?
Ensure brevity in your answer.  1.6. What is the ratio of the Imports(as % of merchandise exports) in Central Europe in 1995 to that in 2002?
Your response must be concise. 0.92. What is the ratio of the Imports(as % of merchandise exports) of Central African Republic in 1995 to that in 2002?
Provide a short and direct response. 1.06. What is the ratio of the Imports(as % of merchandise exports) in Mozambique in 1995 to that in 2002?
Your answer should be very brief. 1.3. What is the ratio of the Imports(as % of merchandise exports) of Turkey in 1995 to that in 2002?
Your response must be concise. 1.01. What is the ratio of the Imports(as % of merchandise exports) of Central Europe in 1995 to that in 2003?
Your answer should be very brief. 0.91. What is the ratio of the Imports(as % of merchandise exports) in Central African Republic in 1995 to that in 2003?
Make the answer very short. 1.15. What is the ratio of the Imports(as % of merchandise exports) of Mozambique in 1995 to that in 2003?
Offer a very short reply. 1.26. What is the ratio of the Imports(as % of merchandise exports) of Turkey in 1995 to that in 2003?
Your answer should be very brief. 1. What is the ratio of the Imports(as % of merchandise exports) in Central Europe in 1996 to that in 1997?
Provide a succinct answer. 0.97. What is the ratio of the Imports(as % of merchandise exports) in Central African Republic in 1996 to that in 1997?
Provide a succinct answer. 0.94. What is the ratio of the Imports(as % of merchandise exports) of Mozambique in 1996 to that in 1997?
Keep it short and to the point. 1.02. What is the ratio of the Imports(as % of merchandise exports) of Turkey in 1996 to that in 1997?
Make the answer very short. 0.97. What is the ratio of the Imports(as % of merchandise exports) in Central Europe in 1996 to that in 2000?
Your response must be concise. 0.94. What is the ratio of the Imports(as % of merchandise exports) of Central African Republic in 1996 to that in 2000?
Give a very brief answer. 1.12. What is the ratio of the Imports(as % of merchandise exports) of Mozambique in 1996 to that in 2000?
Offer a very short reply. 0.92. What is the ratio of the Imports(as % of merchandise exports) in Central Europe in 1996 to that in 2001?
Ensure brevity in your answer.  0.93. What is the ratio of the Imports(as % of merchandise exports) in Central African Republic in 1996 to that in 2001?
Ensure brevity in your answer.  0.99. What is the ratio of the Imports(as % of merchandise exports) of Mozambique in 1996 to that in 2001?
Your response must be concise. 1.6. What is the ratio of the Imports(as % of merchandise exports) of Turkey in 1996 to that in 2001?
Offer a terse response. 1.04. What is the ratio of the Imports(as % of merchandise exports) in Central Europe in 1996 to that in 2002?
Offer a terse response. 0.92. What is the ratio of the Imports(as % of merchandise exports) in Central African Republic in 1996 to that in 2002?
Your answer should be compact. 1. What is the ratio of the Imports(as % of merchandise exports) of Mozambique in 1996 to that in 2002?
Provide a short and direct response. 1.31. What is the ratio of the Imports(as % of merchandise exports) in Turkey in 1996 to that in 2002?
Your response must be concise. 1.03. What is the ratio of the Imports(as % of merchandise exports) in Central Europe in 1996 to that in 2003?
Your answer should be compact. 0.9. What is the ratio of the Imports(as % of merchandise exports) of Central African Republic in 1996 to that in 2003?
Your response must be concise. 1.08. What is the ratio of the Imports(as % of merchandise exports) of Mozambique in 1996 to that in 2003?
Ensure brevity in your answer.  1.26. What is the ratio of the Imports(as % of merchandise exports) of Turkey in 1996 to that in 2003?
Your answer should be compact. 1.02. What is the ratio of the Imports(as % of merchandise exports) of Central Europe in 1997 to that in 2000?
Ensure brevity in your answer.  0.97. What is the ratio of the Imports(as % of merchandise exports) of Central African Republic in 1997 to that in 2000?
Make the answer very short. 1.19. What is the ratio of the Imports(as % of merchandise exports) of Mozambique in 1997 to that in 2000?
Your response must be concise. 0.9. What is the ratio of the Imports(as % of merchandise exports) of Turkey in 1997 to that in 2000?
Keep it short and to the point. 1.02. What is the ratio of the Imports(as % of merchandise exports) in Central Europe in 1997 to that in 2001?
Give a very brief answer. 0.96. What is the ratio of the Imports(as % of merchandise exports) in Central African Republic in 1997 to that in 2001?
Provide a succinct answer. 1.06. What is the ratio of the Imports(as % of merchandise exports) of Mozambique in 1997 to that in 2001?
Keep it short and to the point. 1.57. What is the ratio of the Imports(as % of merchandise exports) in Turkey in 1997 to that in 2001?
Offer a very short reply. 1.08. What is the ratio of the Imports(as % of merchandise exports) of Central Europe in 1997 to that in 2002?
Provide a succinct answer. 0.95. What is the ratio of the Imports(as % of merchandise exports) of Central African Republic in 1997 to that in 2002?
Keep it short and to the point. 1.07. What is the ratio of the Imports(as % of merchandise exports) in Mozambique in 1997 to that in 2002?
Provide a succinct answer. 1.28. What is the ratio of the Imports(as % of merchandise exports) in Turkey in 1997 to that in 2002?
Your answer should be very brief. 1.06. What is the ratio of the Imports(as % of merchandise exports) in Central Europe in 1997 to that in 2003?
Offer a very short reply. 0.93. What is the ratio of the Imports(as % of merchandise exports) of Central African Republic in 1997 to that in 2003?
Offer a very short reply. 1.16. What is the ratio of the Imports(as % of merchandise exports) of Mozambique in 1997 to that in 2003?
Your response must be concise. 1.24. What is the ratio of the Imports(as % of merchandise exports) in Turkey in 1997 to that in 2003?
Make the answer very short. 1.05. What is the ratio of the Imports(as % of merchandise exports) in Central Europe in 2000 to that in 2001?
Give a very brief answer. 0.99. What is the ratio of the Imports(as % of merchandise exports) of Central African Republic in 2000 to that in 2001?
Give a very brief answer. 0.89. What is the ratio of the Imports(as % of merchandise exports) of Mozambique in 2000 to that in 2001?
Your response must be concise. 1.75. What is the ratio of the Imports(as % of merchandise exports) of Turkey in 2000 to that in 2001?
Make the answer very short. 1.05. What is the ratio of the Imports(as % of merchandise exports) of Central Europe in 2000 to that in 2002?
Your answer should be very brief. 0.98. What is the ratio of the Imports(as % of merchandise exports) in Central African Republic in 2000 to that in 2002?
Make the answer very short. 0.9. What is the ratio of the Imports(as % of merchandise exports) of Mozambique in 2000 to that in 2002?
Make the answer very short. 1.43. What is the ratio of the Imports(as % of merchandise exports) in Turkey in 2000 to that in 2002?
Ensure brevity in your answer.  1.04. What is the ratio of the Imports(as % of merchandise exports) in Central Europe in 2000 to that in 2003?
Your answer should be compact. 0.96. What is the ratio of the Imports(as % of merchandise exports) of Central African Republic in 2000 to that in 2003?
Give a very brief answer. 0.97. What is the ratio of the Imports(as % of merchandise exports) in Mozambique in 2000 to that in 2003?
Offer a terse response. 1.37. What is the ratio of the Imports(as % of merchandise exports) in Turkey in 2000 to that in 2003?
Offer a terse response. 1.03. What is the ratio of the Imports(as % of merchandise exports) in Central Europe in 2001 to that in 2002?
Give a very brief answer. 0.99. What is the ratio of the Imports(as % of merchandise exports) in Central African Republic in 2001 to that in 2002?
Make the answer very short. 1.01. What is the ratio of the Imports(as % of merchandise exports) of Mozambique in 2001 to that in 2002?
Provide a succinct answer. 0.82. What is the ratio of the Imports(as % of merchandise exports) in Turkey in 2001 to that in 2002?
Your response must be concise. 0.98. What is the ratio of the Imports(as % of merchandise exports) in Central Europe in 2001 to that in 2003?
Make the answer very short. 0.97. What is the ratio of the Imports(as % of merchandise exports) of Central African Republic in 2001 to that in 2003?
Ensure brevity in your answer.  1.09. What is the ratio of the Imports(as % of merchandise exports) in Mozambique in 2001 to that in 2003?
Provide a short and direct response. 0.79. What is the ratio of the Imports(as % of merchandise exports) of Turkey in 2001 to that in 2003?
Offer a very short reply. 0.98. What is the ratio of the Imports(as % of merchandise exports) of Central Europe in 2002 to that in 2003?
Your response must be concise. 0.98. What is the ratio of the Imports(as % of merchandise exports) in Central African Republic in 2002 to that in 2003?
Make the answer very short. 1.08. What is the ratio of the Imports(as % of merchandise exports) in Mozambique in 2002 to that in 2003?
Give a very brief answer. 0.96. What is the difference between the highest and the second highest Imports(as % of merchandise exports) in Central Europe?
Your answer should be very brief. 1.54. What is the difference between the highest and the second highest Imports(as % of merchandise exports) of Central African Republic?
Your response must be concise. 0.51. What is the difference between the highest and the second highest Imports(as % of merchandise exports) in Mozambique?
Your answer should be very brief. 5.68. What is the difference between the highest and the second highest Imports(as % of merchandise exports) of Turkey?
Offer a terse response. 1.59. What is the difference between the highest and the lowest Imports(as % of merchandise exports) of Central Europe?
Ensure brevity in your answer.  7.93. What is the difference between the highest and the lowest Imports(as % of merchandise exports) in Central African Republic?
Give a very brief answer. 10.45. What is the difference between the highest and the lowest Imports(as % of merchandise exports) of Mozambique?
Provide a succinct answer. 29.07. What is the difference between the highest and the lowest Imports(as % of merchandise exports) of Turkey?
Your response must be concise. 5.25. 